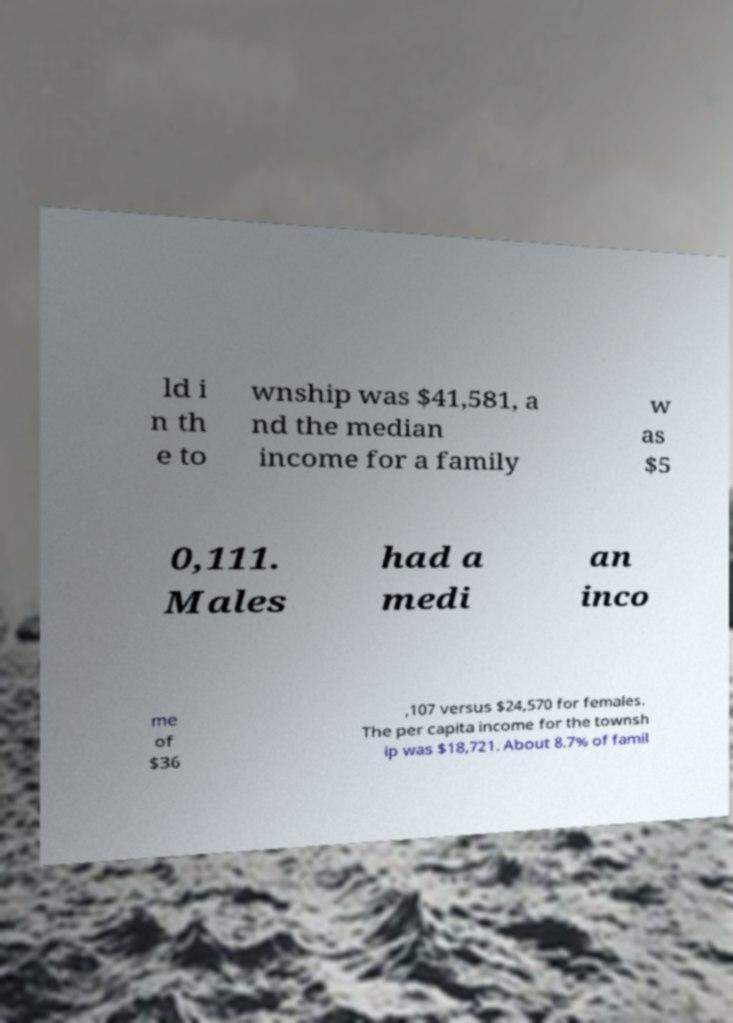Could you assist in decoding the text presented in this image and type it out clearly? ld i n th e to wnship was $41,581, a nd the median income for a family w as $5 0,111. Males had a medi an inco me of $36 ,107 versus $24,570 for females. The per capita income for the townsh ip was $18,721. About 8.7% of famil 